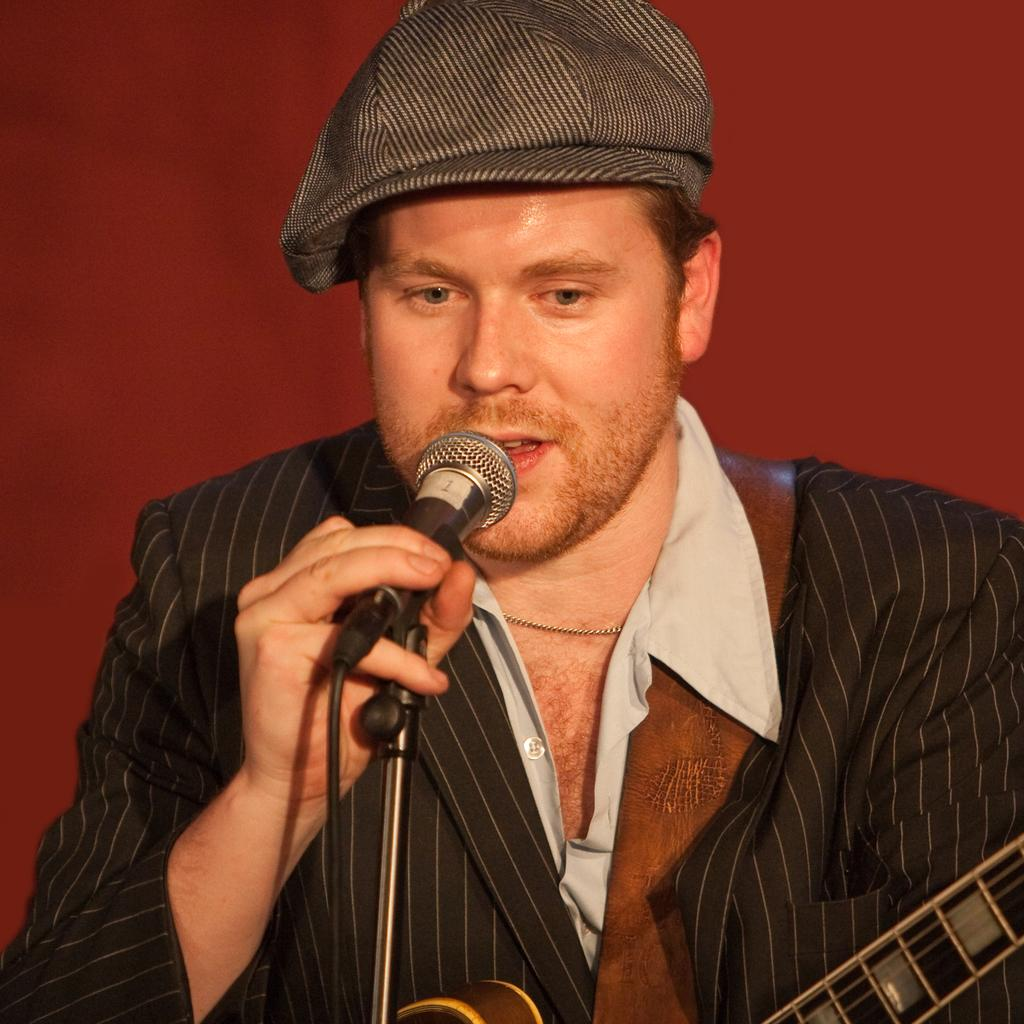Who is the main subject in the image? There is a man in the image. What is the man wearing? The man is wearing a black dress. What is the man holding in his hand? The man is holding a mic in his hand. What is the man doing in the image? The man is singing something. What else is the man holding in his other hand? The man has a musical instrument in his other hand. What type of sand can be seen in the image? There is no sand present in the image. Can you describe the grass in the image? There is no grass present in the image. 